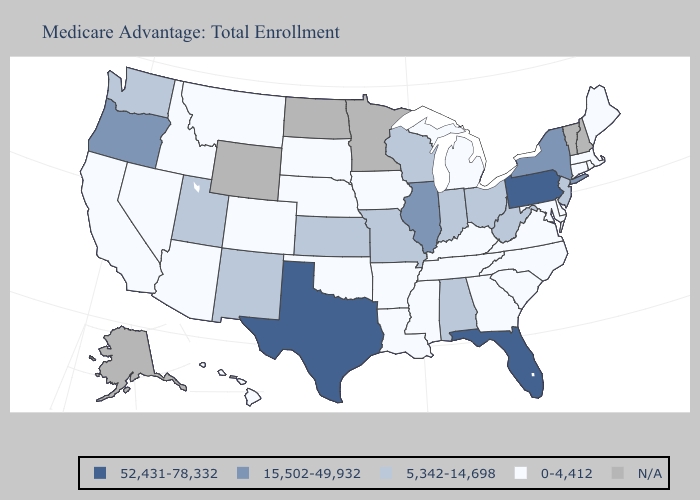What is the value of Delaware?
Give a very brief answer. 0-4,412. Does Tennessee have the highest value in the South?
Be succinct. No. Among the states that border Oregon , does Washington have the highest value?
Quick response, please. Yes. What is the lowest value in the MidWest?
Write a very short answer. 0-4,412. Which states have the highest value in the USA?
Short answer required. Florida, Pennsylvania, Texas. What is the value of Alaska?
Quick response, please. N/A. Name the states that have a value in the range 0-4,412?
Write a very short answer. Arkansas, Arizona, California, Colorado, Connecticut, Delaware, Georgia, Hawaii, Iowa, Idaho, Kentucky, Louisiana, Massachusetts, Maryland, Maine, Michigan, Mississippi, Montana, North Carolina, Nebraska, Nevada, Oklahoma, Rhode Island, South Carolina, South Dakota, Tennessee, Virginia. What is the value of Wisconsin?
Answer briefly. 5,342-14,698. Does Pennsylvania have the highest value in the USA?
Answer briefly. Yes. Name the states that have a value in the range 0-4,412?
Be succinct. Arkansas, Arizona, California, Colorado, Connecticut, Delaware, Georgia, Hawaii, Iowa, Idaho, Kentucky, Louisiana, Massachusetts, Maryland, Maine, Michigan, Mississippi, Montana, North Carolina, Nebraska, Nevada, Oklahoma, Rhode Island, South Carolina, South Dakota, Tennessee, Virginia. Does Indiana have the lowest value in the USA?
Concise answer only. No. What is the highest value in states that border Arizona?
Be succinct. 5,342-14,698. What is the highest value in the USA?
Quick response, please. 52,431-78,332. 